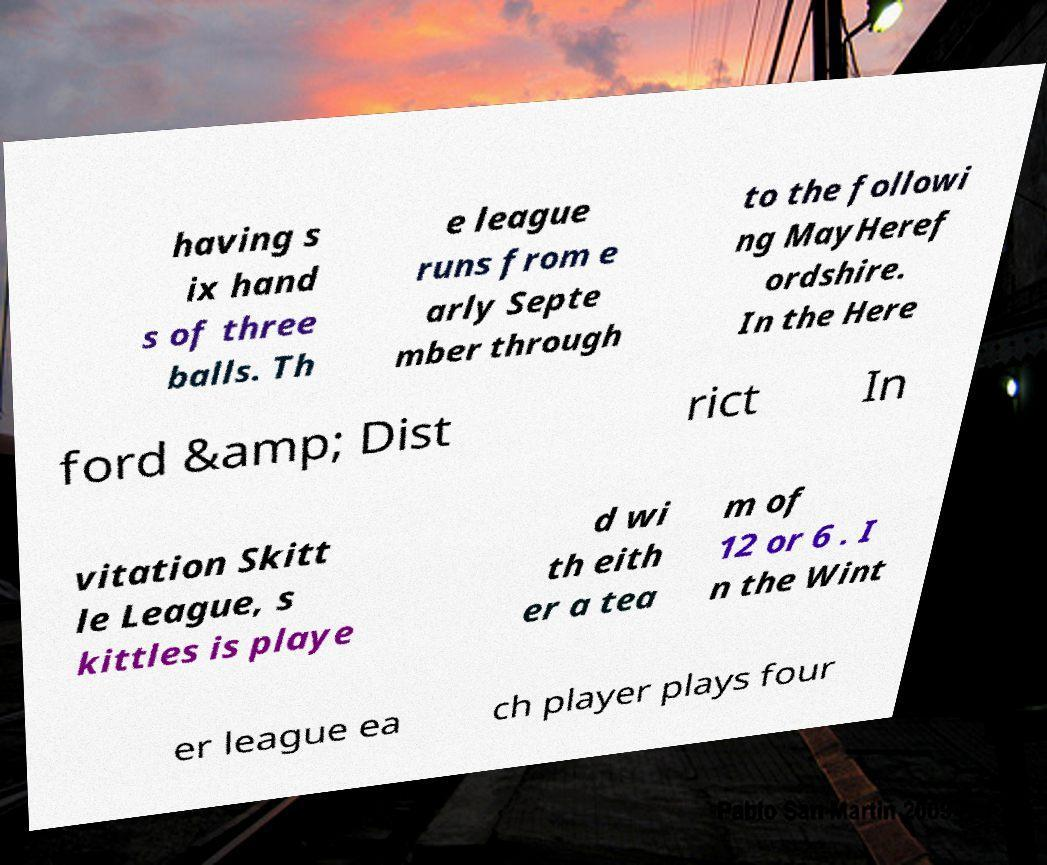Please identify and transcribe the text found in this image. having s ix hand s of three balls. Th e league runs from e arly Septe mber through to the followi ng MayHeref ordshire. In the Here ford &amp; Dist rict In vitation Skitt le League, s kittles is playe d wi th eith er a tea m of 12 or 6 . I n the Wint er league ea ch player plays four 